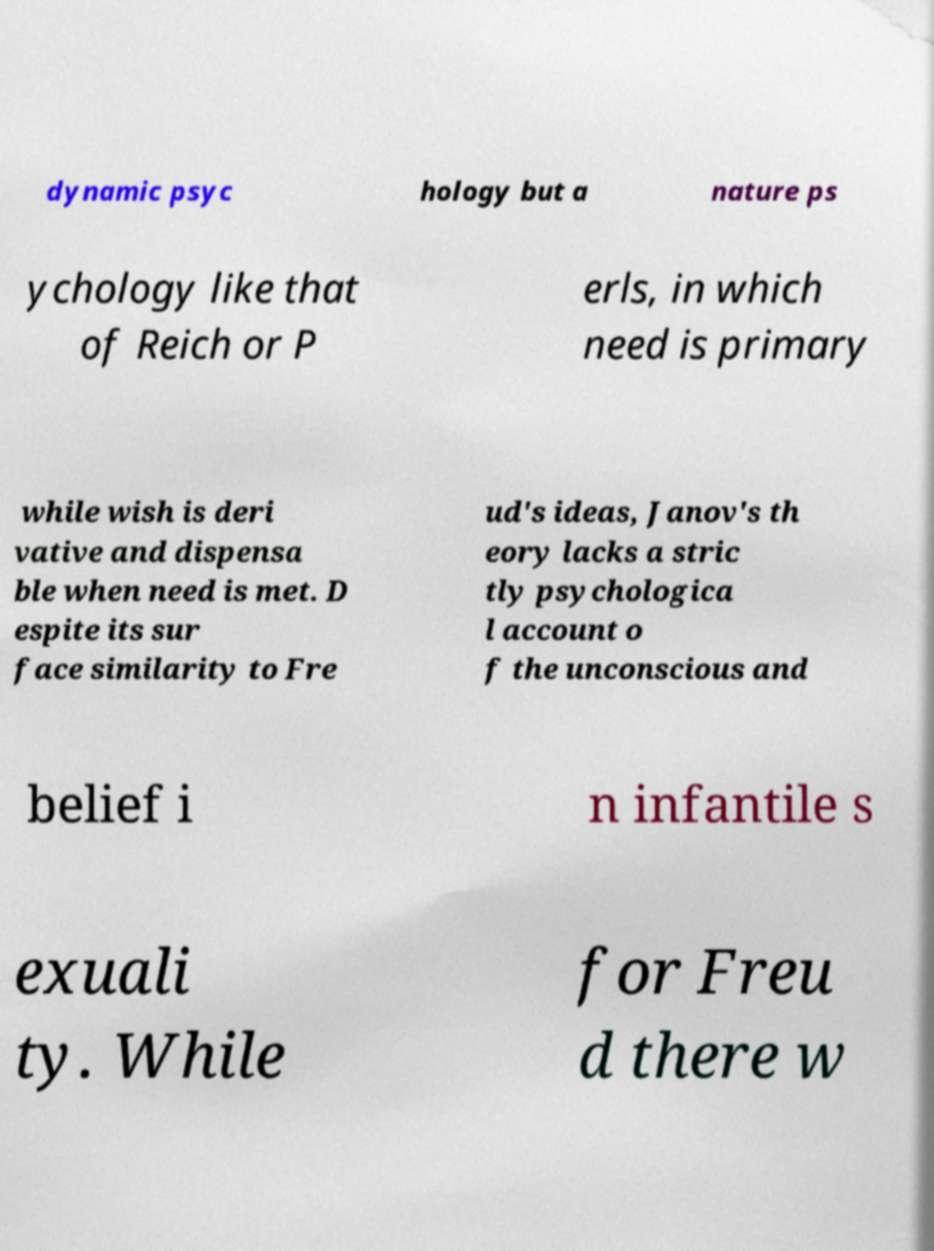Please identify and transcribe the text found in this image. dynamic psyc hology but a nature ps ychology like that of Reich or P erls, in which need is primary while wish is deri vative and dispensa ble when need is met. D espite its sur face similarity to Fre ud's ideas, Janov's th eory lacks a stric tly psychologica l account o f the unconscious and belief i n infantile s exuali ty. While for Freu d there w 